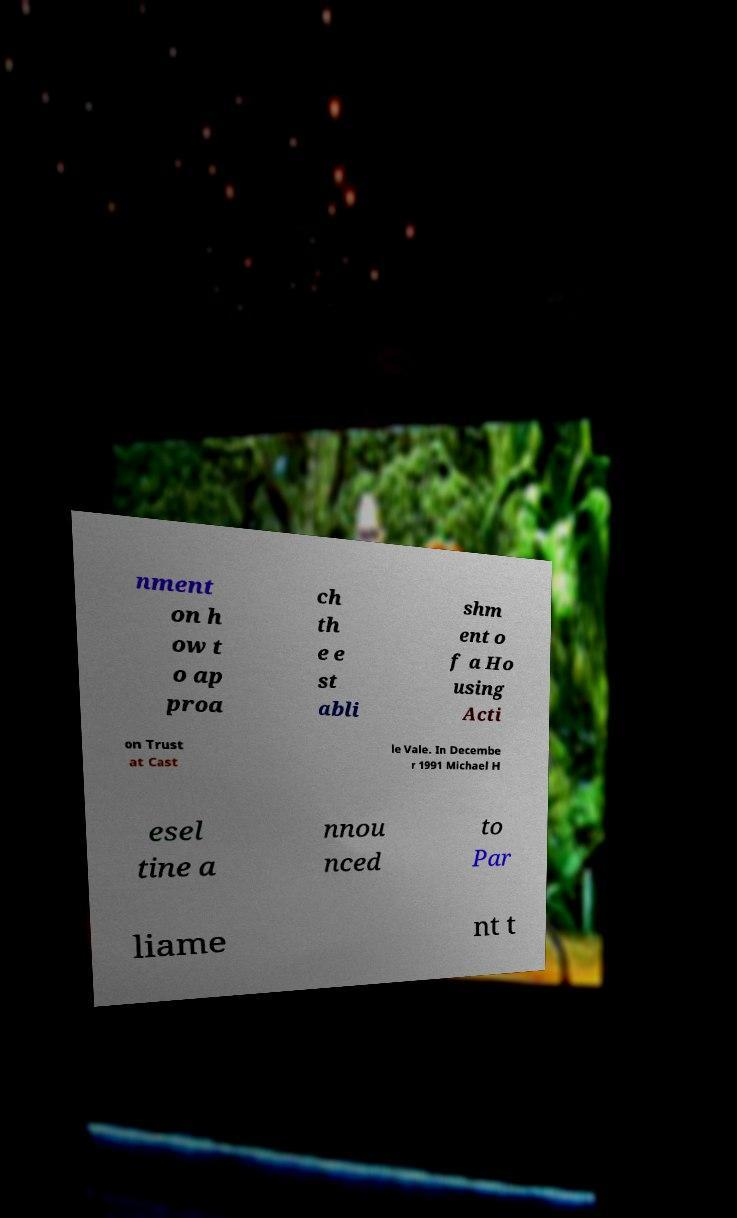I need the written content from this picture converted into text. Can you do that? nment on h ow t o ap proa ch th e e st abli shm ent o f a Ho using Acti on Trust at Cast le Vale. In Decembe r 1991 Michael H esel tine a nnou nced to Par liame nt t 